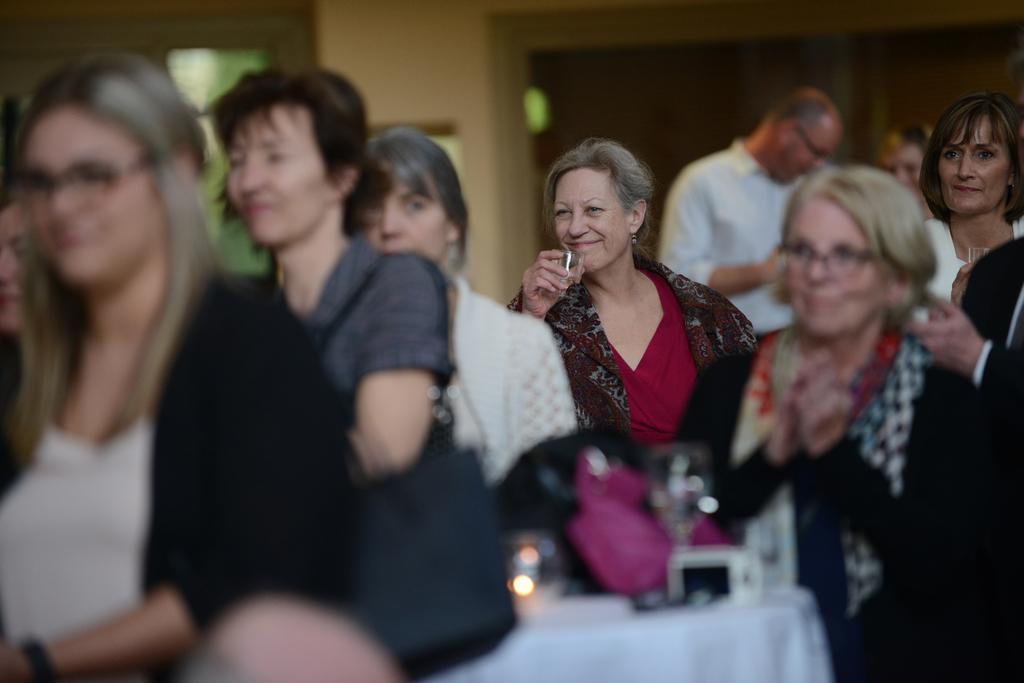In one or two sentences, can you explain what this image depicts? In the image there are many old women sitting on chairs clapping and some are holding glass, in the back there is a man standing, this seems to be inside a conference hall. 